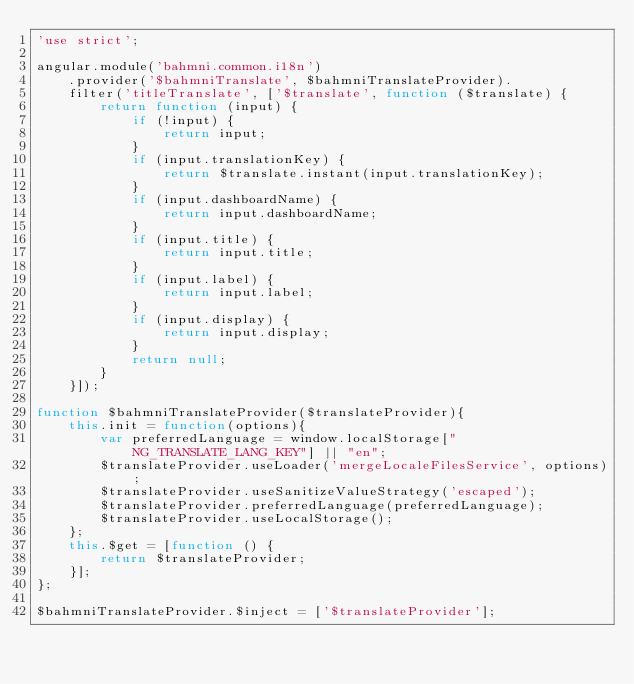<code> <loc_0><loc_0><loc_500><loc_500><_JavaScript_>'use strict';

angular.module('bahmni.common.i18n')
    .provider('$bahmniTranslate', $bahmniTranslateProvider).
    filter('titleTranslate', ['$translate', function ($translate) {
        return function (input) {
            if (!input) {
                return input;
            }
            if (input.translationKey) {
                return $translate.instant(input.translationKey);
            }
            if (input.dashboardName) {
                return input.dashboardName;
            }
            if (input.title) {
                return input.title;
            }
            if (input.label) {
                return input.label;
            }
            if (input.display) {
                return input.display;
            }
            return null;
        }
    }]);

function $bahmniTranslateProvider($translateProvider){
    this.init = function(options){
        var preferredLanguage = window.localStorage["NG_TRANSLATE_LANG_KEY"] || "en";
        $translateProvider.useLoader('mergeLocaleFilesService', options);
        $translateProvider.useSanitizeValueStrategy('escaped');
        $translateProvider.preferredLanguage(preferredLanguage);
        $translateProvider.useLocalStorage();
    };
    this.$get = [function () {
        return $translateProvider;
    }];
};

$bahmniTranslateProvider.$inject = ['$translateProvider'];
</code> 